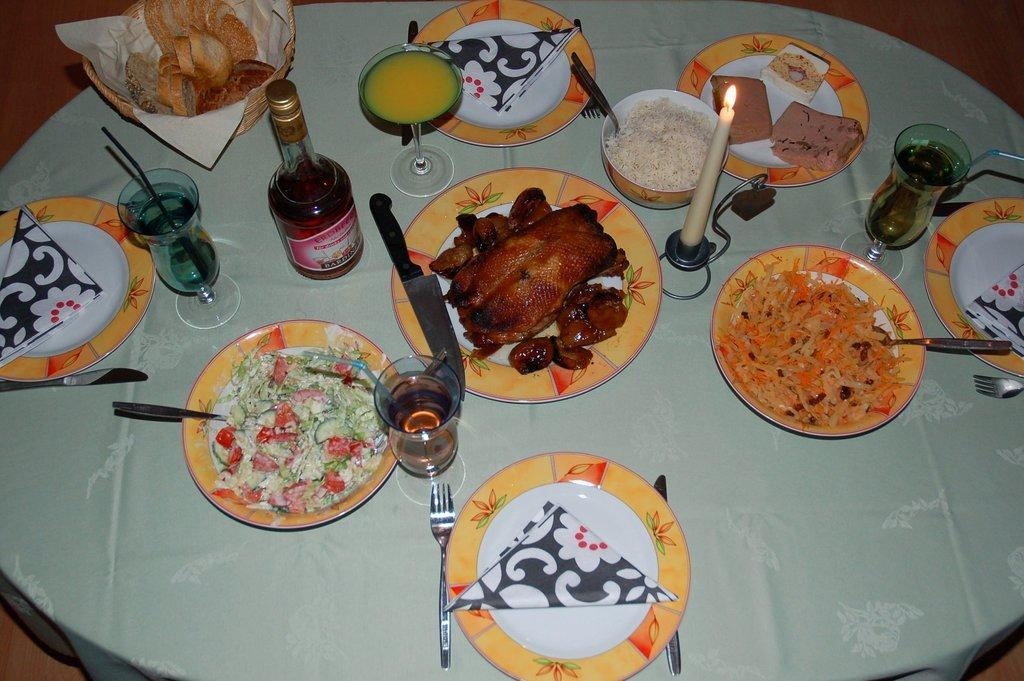What type of furniture is present in the image? There is a table in the image. What items are placed on the table? There are plates, glasses, a bottle, a bowl, a basket, knives, spoons, and a candle on the table. What type of food items can be seen on the table? Several food items are present on the table. How many snakes are coiled around the candle in the image? There are no snakes present in the image; the candle is not associated with any snakes. What type of partner is sitting next to the person in the image? There is no person present in the image, so it is not possible to determine if there is a partner or not. 